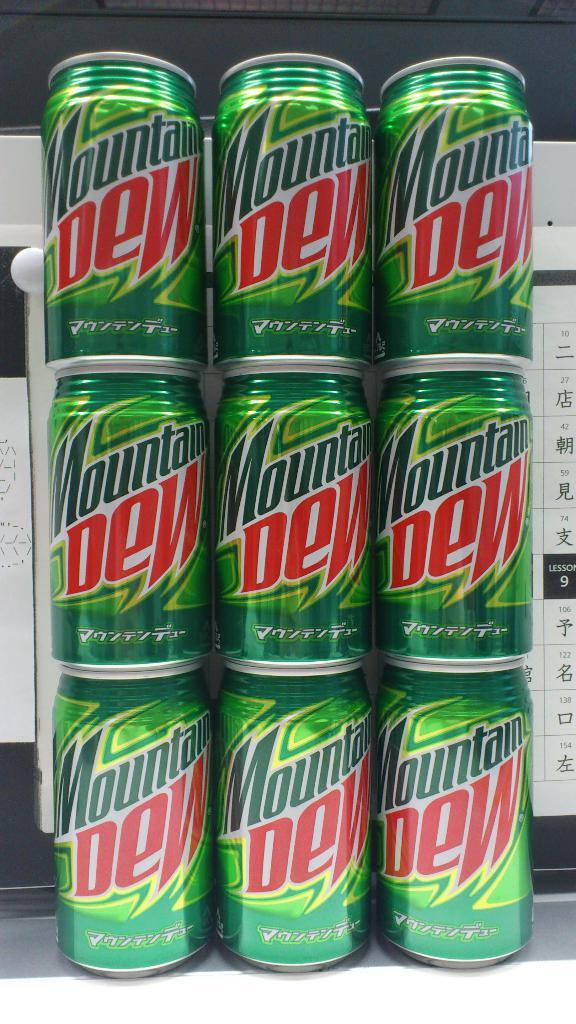<image>
Offer a succinct explanation of the picture presented. A display of stacks of Mountain Dew cans in front of a foreign language sign. 